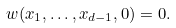Convert formula to latex. <formula><loc_0><loc_0><loc_500><loc_500>w ( x _ { 1 } , \dots , x _ { d - 1 } , 0 ) = 0 .</formula> 